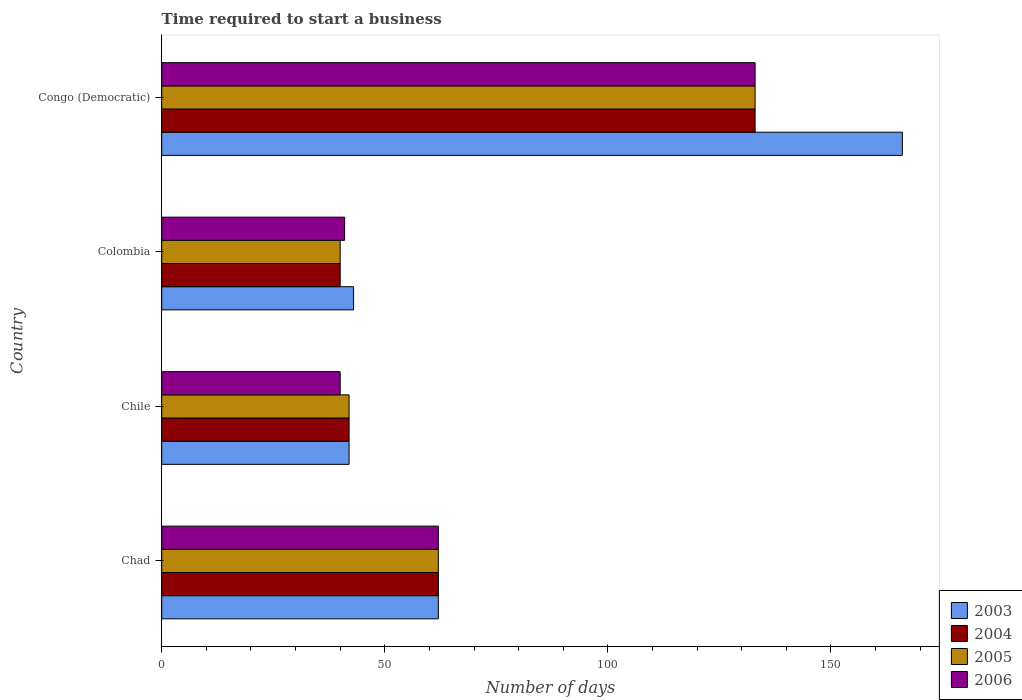How many different coloured bars are there?
Ensure brevity in your answer.  4. Are the number of bars per tick equal to the number of legend labels?
Keep it short and to the point. Yes. How many bars are there on the 3rd tick from the top?
Provide a short and direct response. 4. How many bars are there on the 1st tick from the bottom?
Your response must be concise. 4. What is the label of the 2nd group of bars from the top?
Make the answer very short. Colombia. What is the number of days required to start a business in 2003 in Congo (Democratic)?
Offer a terse response. 166. Across all countries, what is the maximum number of days required to start a business in 2005?
Offer a terse response. 133. Across all countries, what is the minimum number of days required to start a business in 2006?
Provide a succinct answer. 40. In which country was the number of days required to start a business in 2003 maximum?
Keep it short and to the point. Congo (Democratic). What is the total number of days required to start a business in 2003 in the graph?
Offer a very short reply. 313. What is the difference between the number of days required to start a business in 2004 in Colombia and that in Congo (Democratic)?
Give a very brief answer. -93. What is the difference between the number of days required to start a business in 2005 in Chad and the number of days required to start a business in 2006 in Congo (Democratic)?
Make the answer very short. -71. What is the average number of days required to start a business in 2004 per country?
Make the answer very short. 69.25. What is the ratio of the number of days required to start a business in 2004 in Chad to that in Chile?
Keep it short and to the point. 1.48. Is the difference between the number of days required to start a business in 2003 in Chad and Colombia greater than the difference between the number of days required to start a business in 2005 in Chad and Colombia?
Offer a terse response. No. What is the difference between the highest and the second highest number of days required to start a business in 2005?
Provide a short and direct response. 71. What is the difference between the highest and the lowest number of days required to start a business in 2005?
Your response must be concise. 93. What does the 1st bar from the top in Chile represents?
Keep it short and to the point. 2006. How many countries are there in the graph?
Ensure brevity in your answer.  4. Are the values on the major ticks of X-axis written in scientific E-notation?
Provide a succinct answer. No. Does the graph contain any zero values?
Offer a very short reply. No. Where does the legend appear in the graph?
Offer a terse response. Bottom right. How many legend labels are there?
Your answer should be compact. 4. How are the legend labels stacked?
Make the answer very short. Vertical. What is the title of the graph?
Your response must be concise. Time required to start a business. What is the label or title of the X-axis?
Offer a very short reply. Number of days. What is the Number of days of 2003 in Chad?
Your response must be concise. 62. What is the Number of days in 2005 in Chad?
Keep it short and to the point. 62. What is the Number of days in 2003 in Chile?
Your answer should be compact. 42. What is the Number of days in 2004 in Chile?
Your response must be concise. 42. What is the Number of days of 2005 in Chile?
Give a very brief answer. 42. What is the Number of days of 2006 in Chile?
Make the answer very short. 40. What is the Number of days of 2003 in Colombia?
Ensure brevity in your answer.  43. What is the Number of days in 2005 in Colombia?
Offer a terse response. 40. What is the Number of days in 2006 in Colombia?
Your answer should be compact. 41. What is the Number of days in 2003 in Congo (Democratic)?
Make the answer very short. 166. What is the Number of days of 2004 in Congo (Democratic)?
Give a very brief answer. 133. What is the Number of days in 2005 in Congo (Democratic)?
Keep it short and to the point. 133. What is the Number of days in 2006 in Congo (Democratic)?
Keep it short and to the point. 133. Across all countries, what is the maximum Number of days of 2003?
Offer a terse response. 166. Across all countries, what is the maximum Number of days of 2004?
Provide a succinct answer. 133. Across all countries, what is the maximum Number of days in 2005?
Provide a succinct answer. 133. Across all countries, what is the maximum Number of days in 2006?
Offer a terse response. 133. Across all countries, what is the minimum Number of days of 2006?
Your response must be concise. 40. What is the total Number of days in 2003 in the graph?
Give a very brief answer. 313. What is the total Number of days of 2004 in the graph?
Ensure brevity in your answer.  277. What is the total Number of days of 2005 in the graph?
Provide a succinct answer. 277. What is the total Number of days in 2006 in the graph?
Your answer should be compact. 276. What is the difference between the Number of days in 2003 in Chad and that in Chile?
Your answer should be compact. 20. What is the difference between the Number of days in 2006 in Chad and that in Chile?
Your response must be concise. 22. What is the difference between the Number of days in 2003 in Chad and that in Colombia?
Make the answer very short. 19. What is the difference between the Number of days in 2005 in Chad and that in Colombia?
Ensure brevity in your answer.  22. What is the difference between the Number of days in 2003 in Chad and that in Congo (Democratic)?
Provide a succinct answer. -104. What is the difference between the Number of days of 2004 in Chad and that in Congo (Democratic)?
Make the answer very short. -71. What is the difference between the Number of days of 2005 in Chad and that in Congo (Democratic)?
Make the answer very short. -71. What is the difference between the Number of days of 2006 in Chad and that in Congo (Democratic)?
Provide a succinct answer. -71. What is the difference between the Number of days in 2003 in Chile and that in Colombia?
Keep it short and to the point. -1. What is the difference between the Number of days of 2004 in Chile and that in Colombia?
Make the answer very short. 2. What is the difference between the Number of days of 2005 in Chile and that in Colombia?
Offer a terse response. 2. What is the difference between the Number of days of 2003 in Chile and that in Congo (Democratic)?
Your answer should be compact. -124. What is the difference between the Number of days of 2004 in Chile and that in Congo (Democratic)?
Provide a short and direct response. -91. What is the difference between the Number of days in 2005 in Chile and that in Congo (Democratic)?
Offer a very short reply. -91. What is the difference between the Number of days in 2006 in Chile and that in Congo (Democratic)?
Your response must be concise. -93. What is the difference between the Number of days of 2003 in Colombia and that in Congo (Democratic)?
Provide a succinct answer. -123. What is the difference between the Number of days of 2004 in Colombia and that in Congo (Democratic)?
Ensure brevity in your answer.  -93. What is the difference between the Number of days of 2005 in Colombia and that in Congo (Democratic)?
Offer a very short reply. -93. What is the difference between the Number of days of 2006 in Colombia and that in Congo (Democratic)?
Provide a succinct answer. -92. What is the difference between the Number of days in 2003 in Chad and the Number of days in 2004 in Chile?
Give a very brief answer. 20. What is the difference between the Number of days in 2005 in Chad and the Number of days in 2006 in Colombia?
Offer a very short reply. 21. What is the difference between the Number of days of 2003 in Chad and the Number of days of 2004 in Congo (Democratic)?
Provide a succinct answer. -71. What is the difference between the Number of days of 2003 in Chad and the Number of days of 2005 in Congo (Democratic)?
Keep it short and to the point. -71. What is the difference between the Number of days in 2003 in Chad and the Number of days in 2006 in Congo (Democratic)?
Make the answer very short. -71. What is the difference between the Number of days in 2004 in Chad and the Number of days in 2005 in Congo (Democratic)?
Keep it short and to the point. -71. What is the difference between the Number of days in 2004 in Chad and the Number of days in 2006 in Congo (Democratic)?
Your response must be concise. -71. What is the difference between the Number of days of 2005 in Chad and the Number of days of 2006 in Congo (Democratic)?
Your answer should be very brief. -71. What is the difference between the Number of days of 2003 in Chile and the Number of days of 2004 in Colombia?
Your answer should be compact. 2. What is the difference between the Number of days in 2003 in Chile and the Number of days in 2005 in Colombia?
Give a very brief answer. 2. What is the difference between the Number of days of 2003 in Chile and the Number of days of 2006 in Colombia?
Ensure brevity in your answer.  1. What is the difference between the Number of days of 2004 in Chile and the Number of days of 2006 in Colombia?
Ensure brevity in your answer.  1. What is the difference between the Number of days in 2005 in Chile and the Number of days in 2006 in Colombia?
Keep it short and to the point. 1. What is the difference between the Number of days in 2003 in Chile and the Number of days in 2004 in Congo (Democratic)?
Offer a terse response. -91. What is the difference between the Number of days in 2003 in Chile and the Number of days in 2005 in Congo (Democratic)?
Make the answer very short. -91. What is the difference between the Number of days in 2003 in Chile and the Number of days in 2006 in Congo (Democratic)?
Provide a succinct answer. -91. What is the difference between the Number of days in 2004 in Chile and the Number of days in 2005 in Congo (Democratic)?
Your answer should be compact. -91. What is the difference between the Number of days in 2004 in Chile and the Number of days in 2006 in Congo (Democratic)?
Ensure brevity in your answer.  -91. What is the difference between the Number of days of 2005 in Chile and the Number of days of 2006 in Congo (Democratic)?
Your answer should be compact. -91. What is the difference between the Number of days of 2003 in Colombia and the Number of days of 2004 in Congo (Democratic)?
Give a very brief answer. -90. What is the difference between the Number of days in 2003 in Colombia and the Number of days in 2005 in Congo (Democratic)?
Ensure brevity in your answer.  -90. What is the difference between the Number of days in 2003 in Colombia and the Number of days in 2006 in Congo (Democratic)?
Provide a succinct answer. -90. What is the difference between the Number of days of 2004 in Colombia and the Number of days of 2005 in Congo (Democratic)?
Make the answer very short. -93. What is the difference between the Number of days of 2004 in Colombia and the Number of days of 2006 in Congo (Democratic)?
Offer a terse response. -93. What is the difference between the Number of days in 2005 in Colombia and the Number of days in 2006 in Congo (Democratic)?
Provide a succinct answer. -93. What is the average Number of days in 2003 per country?
Make the answer very short. 78.25. What is the average Number of days of 2004 per country?
Provide a short and direct response. 69.25. What is the average Number of days of 2005 per country?
Ensure brevity in your answer.  69.25. What is the difference between the Number of days of 2003 and Number of days of 2004 in Chad?
Your answer should be very brief. 0. What is the difference between the Number of days in 2003 and Number of days in 2005 in Chad?
Make the answer very short. 0. What is the difference between the Number of days in 2004 and Number of days in 2005 in Chad?
Offer a terse response. 0. What is the difference between the Number of days in 2004 and Number of days in 2006 in Chad?
Offer a very short reply. 0. What is the difference between the Number of days of 2004 and Number of days of 2005 in Chile?
Provide a short and direct response. 0. What is the difference between the Number of days in 2004 and Number of days in 2005 in Colombia?
Your answer should be compact. 0. What is the difference between the Number of days in 2004 and Number of days in 2006 in Colombia?
Your response must be concise. -1. What is the difference between the Number of days of 2005 and Number of days of 2006 in Colombia?
Your answer should be compact. -1. What is the difference between the Number of days of 2003 and Number of days of 2006 in Congo (Democratic)?
Your response must be concise. 33. What is the difference between the Number of days of 2004 and Number of days of 2005 in Congo (Democratic)?
Make the answer very short. 0. What is the difference between the Number of days in 2004 and Number of days in 2006 in Congo (Democratic)?
Provide a short and direct response. 0. What is the ratio of the Number of days in 2003 in Chad to that in Chile?
Keep it short and to the point. 1.48. What is the ratio of the Number of days of 2004 in Chad to that in Chile?
Ensure brevity in your answer.  1.48. What is the ratio of the Number of days of 2005 in Chad to that in Chile?
Offer a very short reply. 1.48. What is the ratio of the Number of days in 2006 in Chad to that in Chile?
Provide a short and direct response. 1.55. What is the ratio of the Number of days in 2003 in Chad to that in Colombia?
Ensure brevity in your answer.  1.44. What is the ratio of the Number of days of 2004 in Chad to that in Colombia?
Give a very brief answer. 1.55. What is the ratio of the Number of days of 2005 in Chad to that in Colombia?
Provide a succinct answer. 1.55. What is the ratio of the Number of days in 2006 in Chad to that in Colombia?
Make the answer very short. 1.51. What is the ratio of the Number of days in 2003 in Chad to that in Congo (Democratic)?
Make the answer very short. 0.37. What is the ratio of the Number of days of 2004 in Chad to that in Congo (Democratic)?
Keep it short and to the point. 0.47. What is the ratio of the Number of days of 2005 in Chad to that in Congo (Democratic)?
Make the answer very short. 0.47. What is the ratio of the Number of days of 2006 in Chad to that in Congo (Democratic)?
Your answer should be very brief. 0.47. What is the ratio of the Number of days of 2003 in Chile to that in Colombia?
Your answer should be very brief. 0.98. What is the ratio of the Number of days in 2006 in Chile to that in Colombia?
Give a very brief answer. 0.98. What is the ratio of the Number of days of 2003 in Chile to that in Congo (Democratic)?
Give a very brief answer. 0.25. What is the ratio of the Number of days in 2004 in Chile to that in Congo (Democratic)?
Offer a very short reply. 0.32. What is the ratio of the Number of days of 2005 in Chile to that in Congo (Democratic)?
Ensure brevity in your answer.  0.32. What is the ratio of the Number of days of 2006 in Chile to that in Congo (Democratic)?
Make the answer very short. 0.3. What is the ratio of the Number of days of 2003 in Colombia to that in Congo (Democratic)?
Your answer should be compact. 0.26. What is the ratio of the Number of days in 2004 in Colombia to that in Congo (Democratic)?
Give a very brief answer. 0.3. What is the ratio of the Number of days in 2005 in Colombia to that in Congo (Democratic)?
Your answer should be compact. 0.3. What is the ratio of the Number of days in 2006 in Colombia to that in Congo (Democratic)?
Offer a very short reply. 0.31. What is the difference between the highest and the second highest Number of days of 2003?
Provide a short and direct response. 104. What is the difference between the highest and the second highest Number of days in 2004?
Your answer should be very brief. 71. What is the difference between the highest and the second highest Number of days of 2006?
Offer a very short reply. 71. What is the difference between the highest and the lowest Number of days in 2003?
Make the answer very short. 124. What is the difference between the highest and the lowest Number of days in 2004?
Your answer should be very brief. 93. What is the difference between the highest and the lowest Number of days of 2005?
Offer a very short reply. 93. What is the difference between the highest and the lowest Number of days of 2006?
Ensure brevity in your answer.  93. 